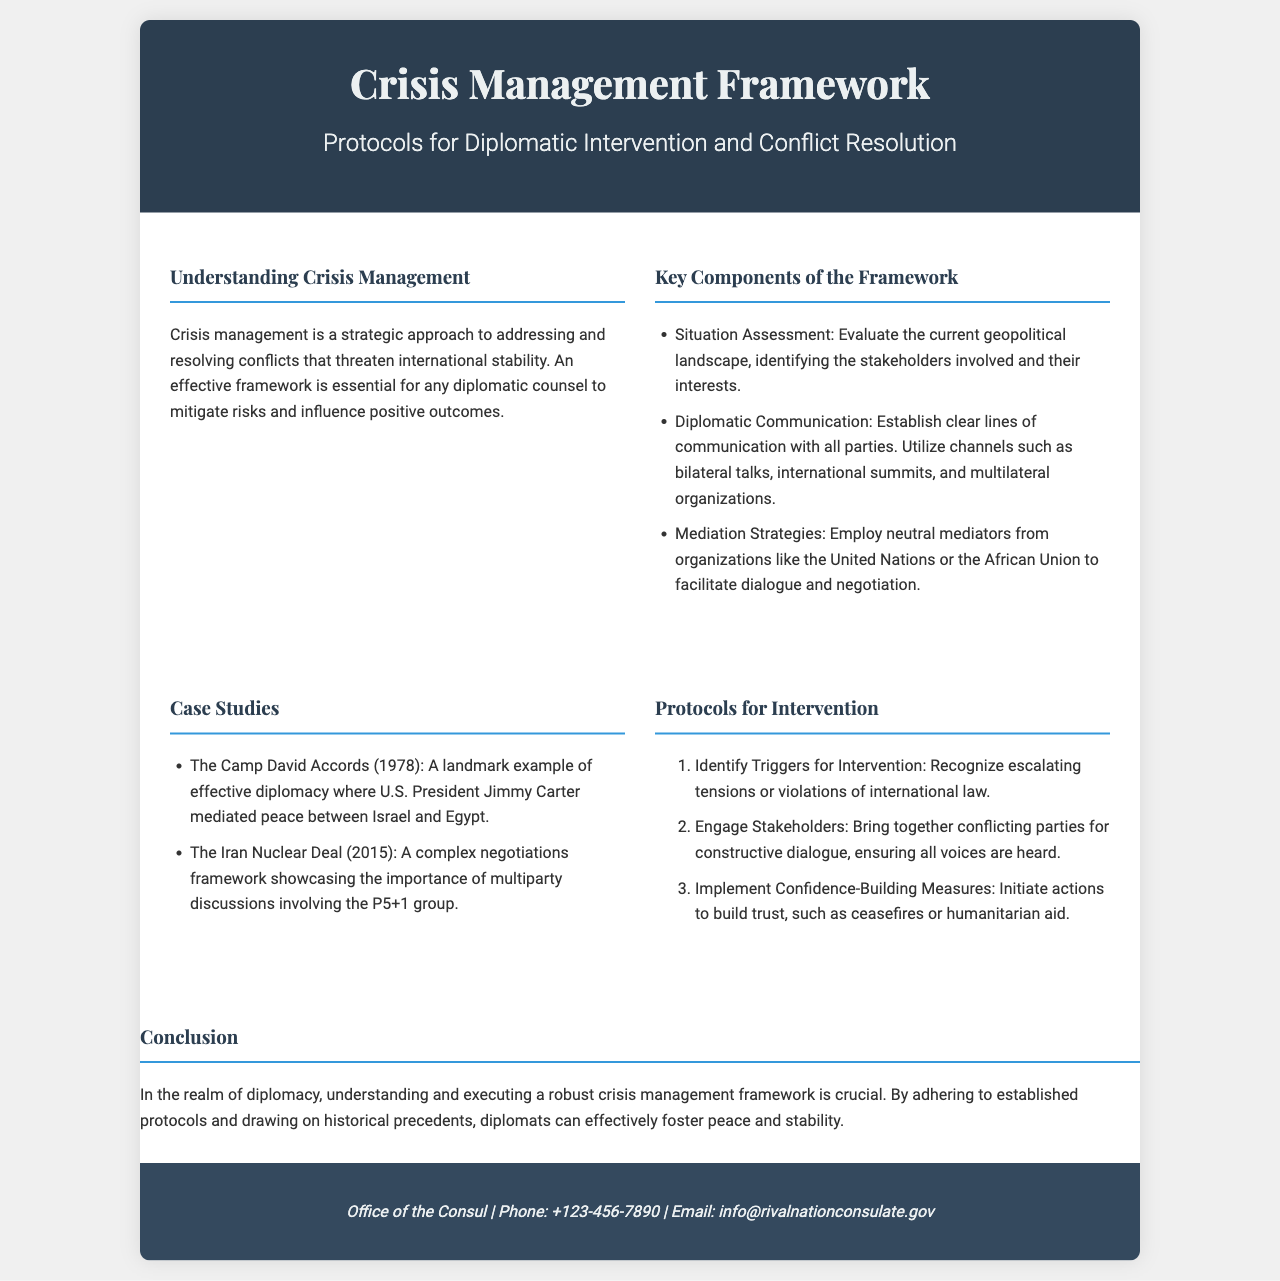what is the title of the brochure? The title of the brochure is presented prominently at the top of the document.
Answer: Crisis Management Framework what year did the Camp David Accords occur? The Camp David Accords are mentioned as a case study with a specific year given in the document.
Answer: 1978 which organization is mentioned for mediation strategies? The document mentions specific organizations that play a role in mediation strategies during crises.
Answer: United Nations what is the third protocol for intervention? The protocols for intervention are listed in an ordered format, where the third one is clearly stated.
Answer: Implement Confidence-Building Measures who mediated the Camp David Accords? The document provides information about key figures in historical case studies, including the Camp David Accords.
Answer: Jimmy Carter what is the contact email provided in the brochure? The contact information at the bottom of the document includes an email address.
Answer: info@rivalnationconsulate.gov what is the main purpose of crisis management? The purpose of crisis management is described in the initial section of the document, focusing on its strategic importance.
Answer: Addressing and resolving conflicts what are the key components of the framework? The document lists key components under a specific section, detailing their roles in crisis management.
Answer: Situation Assessment, Diplomatic Communication, Mediation Strategies how many case studies are presented in the document? The document refers to a list under the Case Studies section that specifies the examples provided.
Answer: Two 